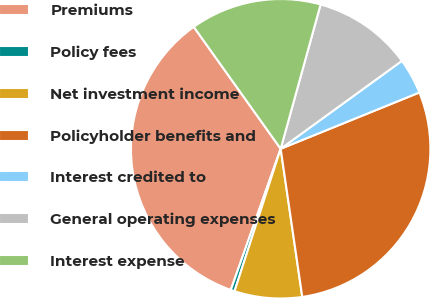Convert chart. <chart><loc_0><loc_0><loc_500><loc_500><pie_chart><fcel>Premiums<fcel>Policy fees<fcel>Net investment income<fcel>Policyholder benefits and<fcel>Interest credited to<fcel>General operating expenses<fcel>Interest expense<nl><fcel>34.74%<fcel>0.42%<fcel>7.29%<fcel>28.83%<fcel>3.85%<fcel>10.72%<fcel>14.15%<nl></chart> 